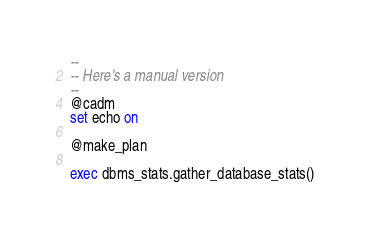Convert code to text. <code><loc_0><loc_0><loc_500><loc_500><_SQL_>--
-- Here's a manual version
--
@cadm
set echo on

@make_plan

exec dbms_stats.gather_database_stats()
</code> 